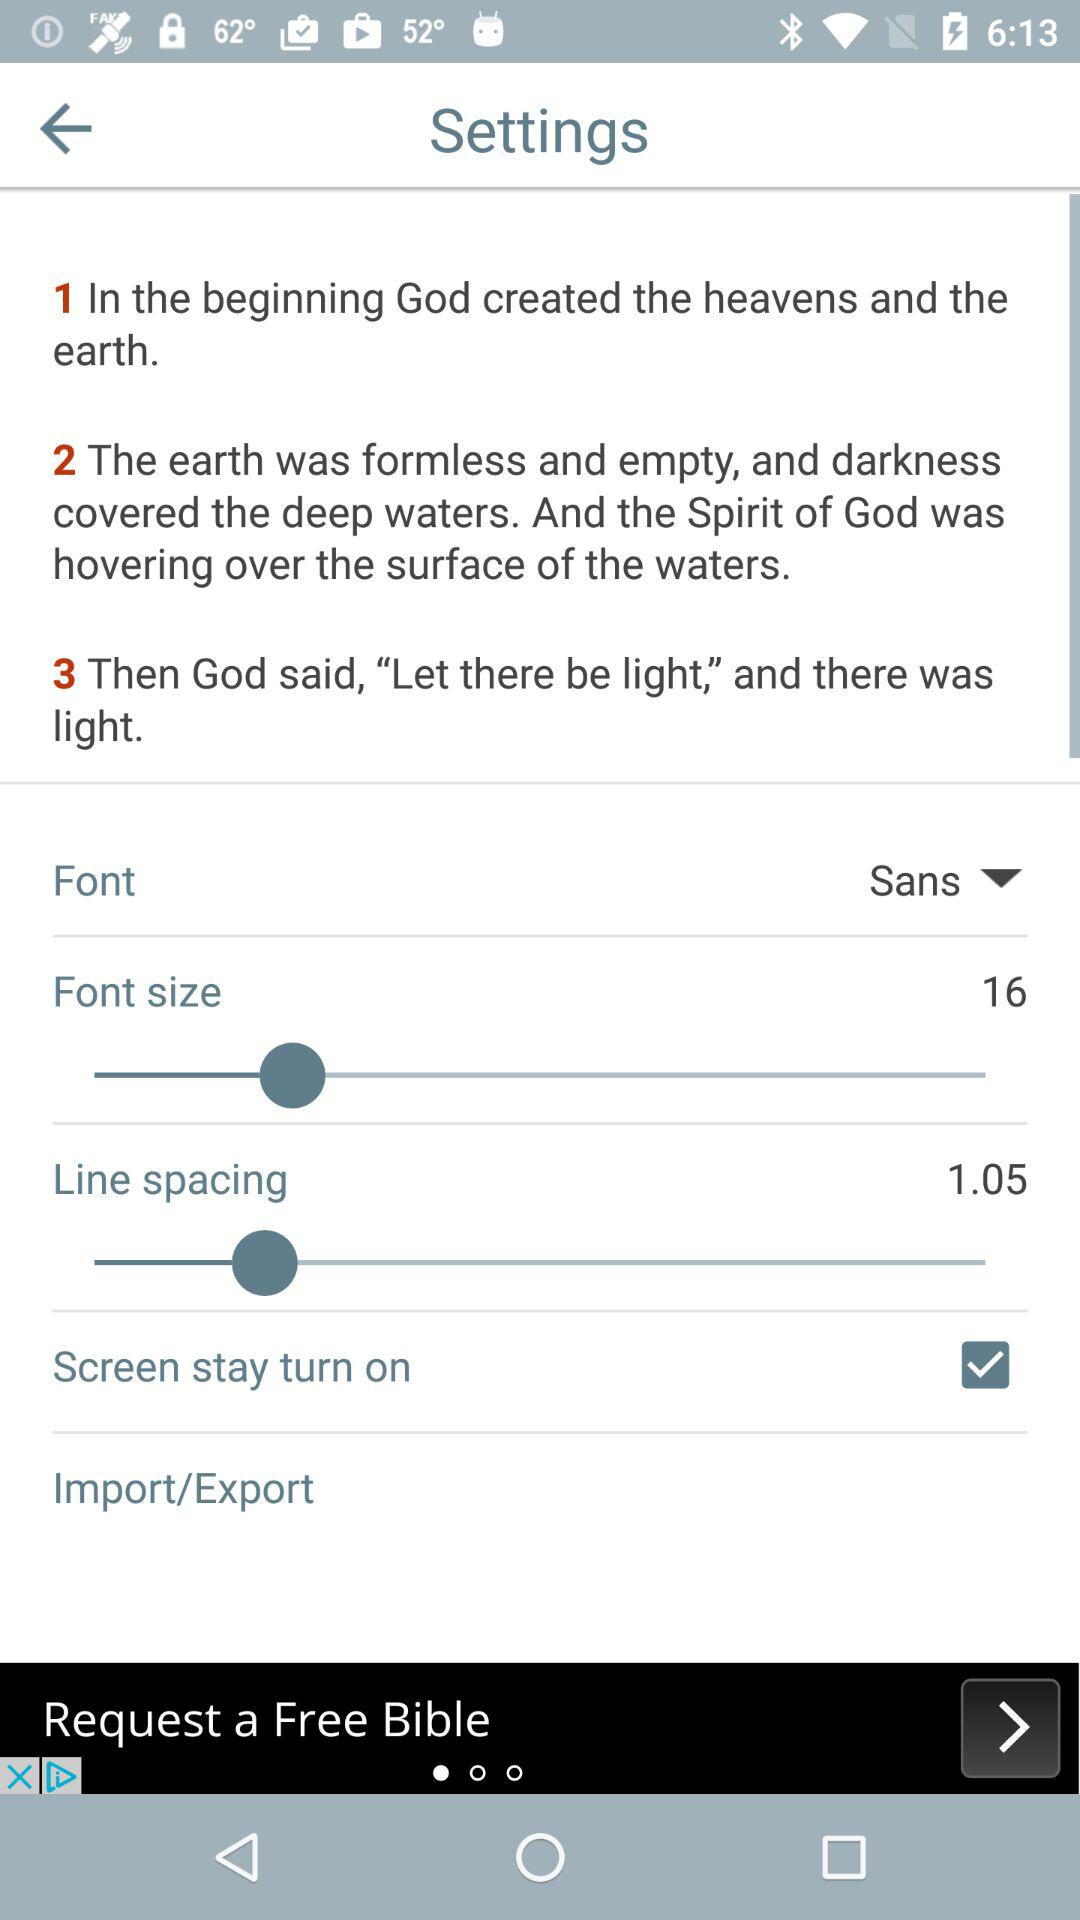What is the value of "Line spacing"? The value of "Line spacing" is 1.05. 